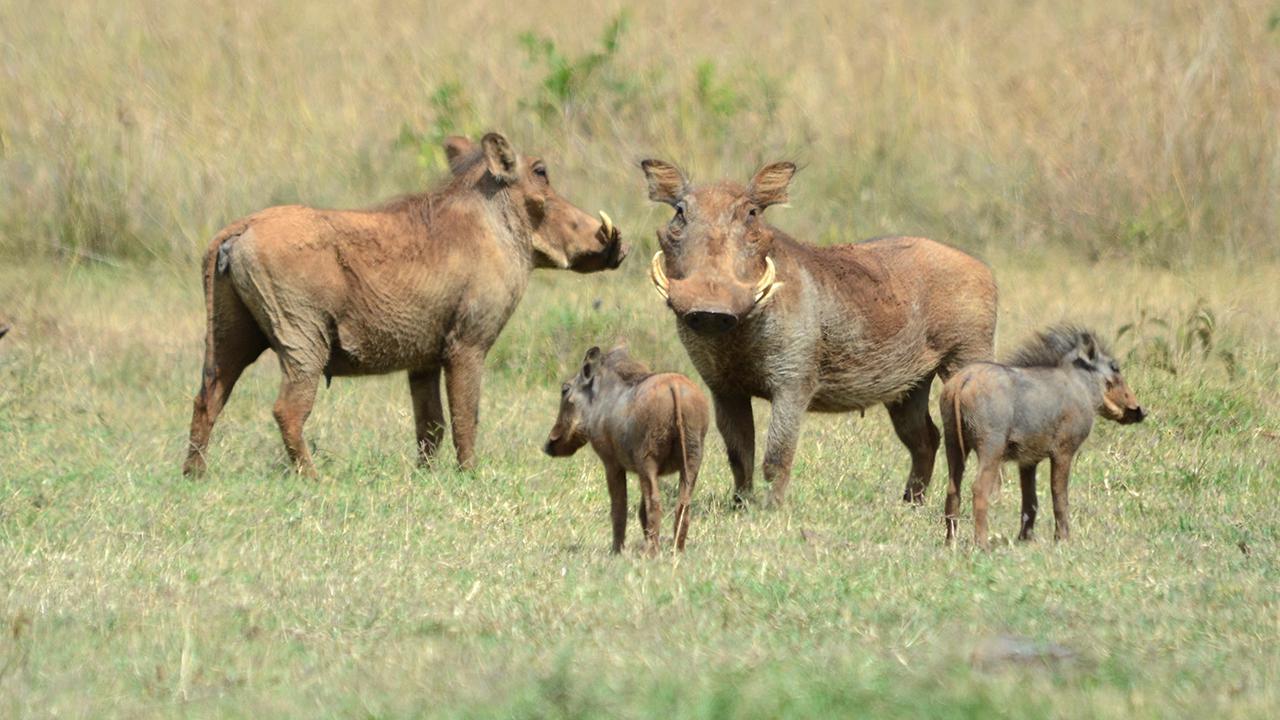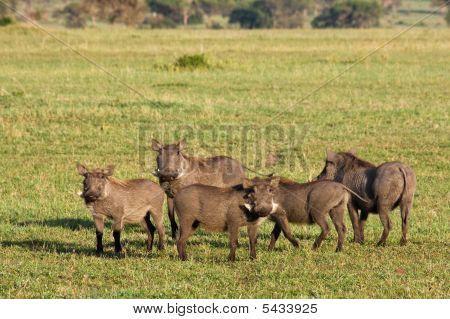The first image is the image on the left, the second image is the image on the right. Given the left and right images, does the statement "There are 4 warthogs in the left image." hold true? Answer yes or no. Yes. The first image is the image on the left, the second image is the image on the right. Given the left and right images, does the statement "one of the images shows a group of hogs standing and facing right." hold true? Answer yes or no. No. 